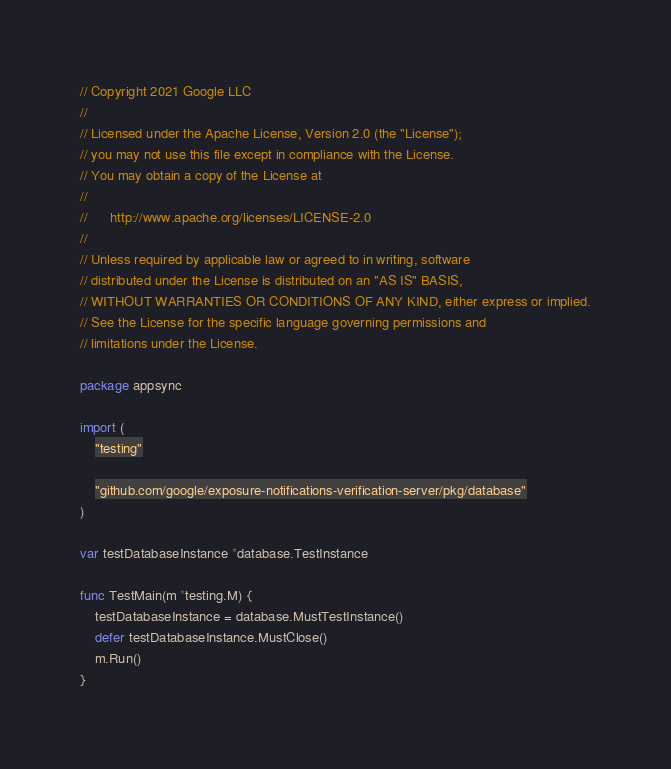<code> <loc_0><loc_0><loc_500><loc_500><_Go_>// Copyright 2021 Google LLC
//
// Licensed under the Apache License, Version 2.0 (the "License");
// you may not use this file except in compliance with the License.
// You may obtain a copy of the License at
//
//      http://www.apache.org/licenses/LICENSE-2.0
//
// Unless required by applicable law or agreed to in writing, software
// distributed under the License is distributed on an "AS IS" BASIS,
// WITHOUT WARRANTIES OR CONDITIONS OF ANY KIND, either express or implied.
// See the License for the specific language governing permissions and
// limitations under the License.

package appsync

import (
	"testing"

	"github.com/google/exposure-notifications-verification-server/pkg/database"
)

var testDatabaseInstance *database.TestInstance

func TestMain(m *testing.M) {
	testDatabaseInstance = database.MustTestInstance()
	defer testDatabaseInstance.MustClose()
	m.Run()
}
</code> 